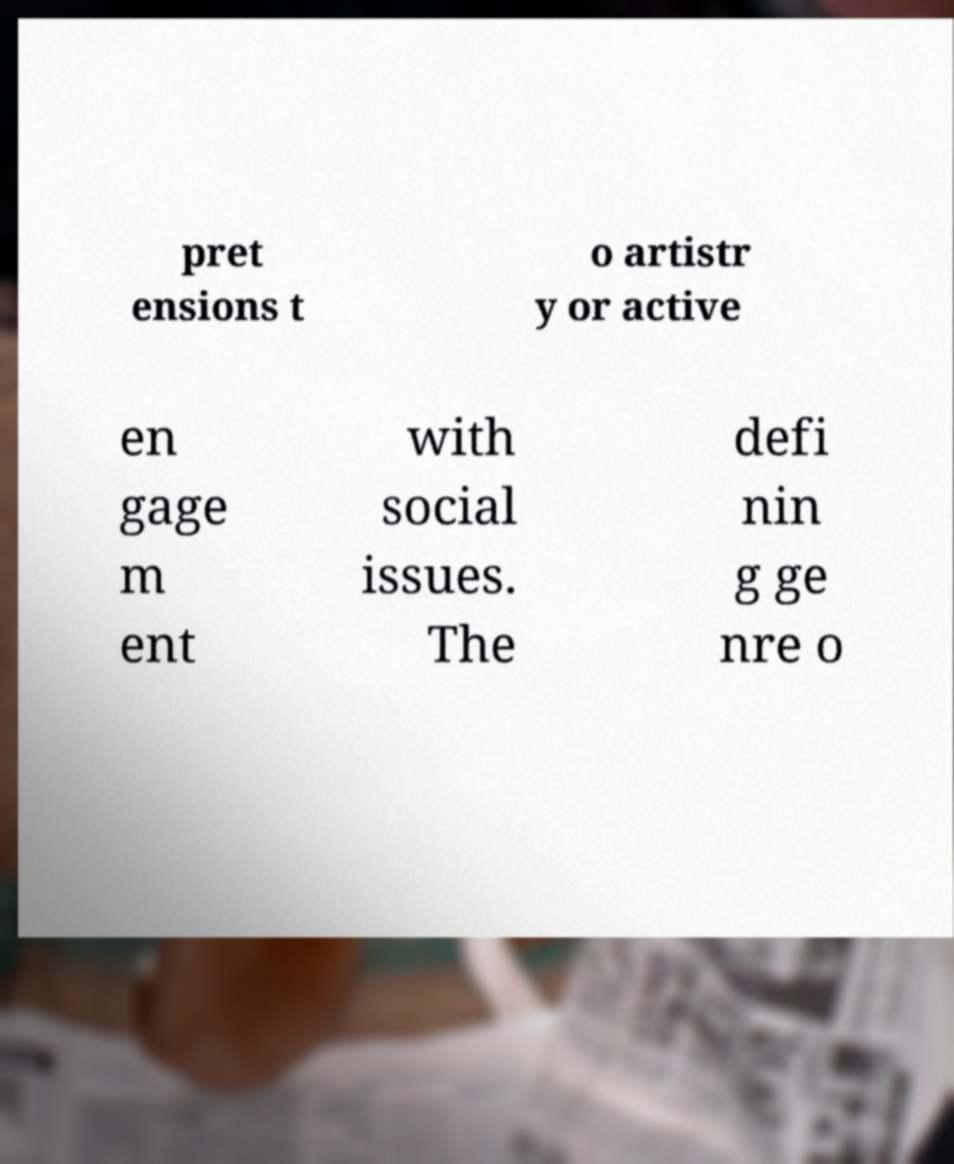Can you accurately transcribe the text from the provided image for me? pret ensions t o artistr y or active en gage m ent with social issues. The defi nin g ge nre o 